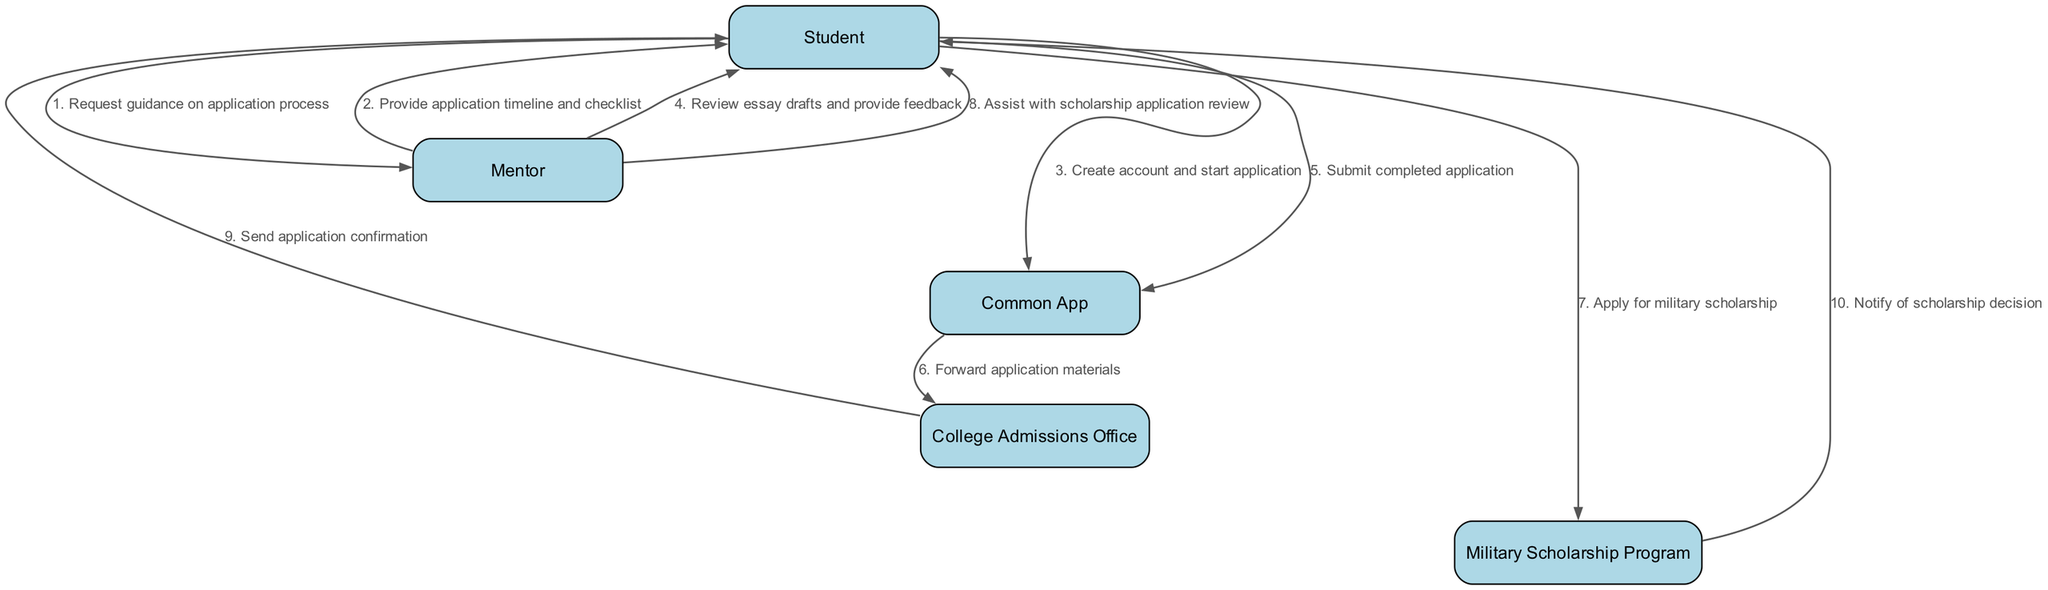What is the first action taken by the Student? The first action taken by the Student is to request guidance on the application process from the Mentor. This can be seen as the initial step on the diagram, indicated by the first arrow pointing from the Student to the Mentor.
Answer: Request guidance on application process How many total participants are there in the diagram? The total number of participants can be counted from the list provided at the beginning of the diagram. There are five distinct participants: Student, Mentor, Common App, College Admissions Office, and Military Scholarship Program.
Answer: Five Who receives the application materials after submission? After the Student submits the completed application, the Common App forwards the application materials to the College Admissions Office, as indicated by the directed arrow between these two nodes.
Answer: College Admissions Office What does the Mentor assist with after the Student applies for the military scholarship? After the Student applies for the military scholarship, the Mentor assists with the scholarship application review, which is shown in the diagram as an arrow from the Mentor to the Student.
Answer: Assist with scholarship application review What is the last action taken by the Military Scholarship Program? The last action taken by the Military Scholarship Program is to notify the Student of the scholarship decision. This can be identified as the final step in the sequence diagram, where the arrow from the Military Scholarship Program points to the Student.
Answer: Notify of scholarship decision How many messages are exchanged between the Student and Mentor? By analyzing the sequence of messages exchanged in the diagram, we observe that there are three messages between the Student and the Mentor: requesting guidance, providing application timeline, and assisting with the scholarship application review.
Answer: Three What information does the College Admissions Office send to the Student? The College Admissions Office sends application confirmation to the Student as their action in the sequence, which is shown by the directed edge from the College Admissions Office to the Student.
Answer: Send application confirmation Which entity is responsible for forwarding application materials? The entity responsible for forwarding application materials is the Common App. This responsibility is highlighted by the arrow explaining that the Common App forwards the application materials to the College Admissions Office.
Answer: Common App 